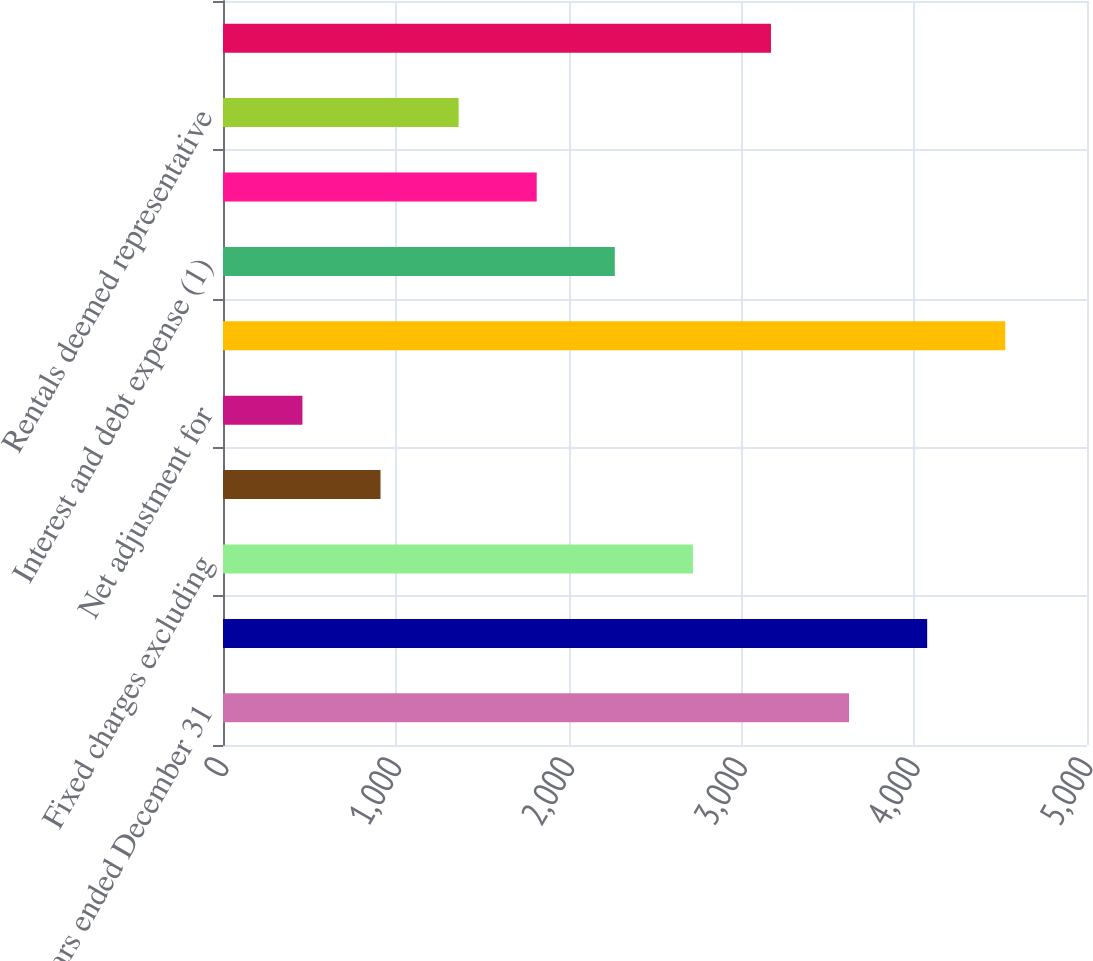<chart> <loc_0><loc_0><loc_500><loc_500><bar_chart><fcel>Years ended December 31<fcel>Earnings before federal taxes<fcel>Fixed charges excluding<fcel>Amortization of previously<fcel>Net adjustment for<fcel>Earnings available for fixed<fcel>Interest and debt expense (1)<fcel>Interest capitalized during<fcel>Rentals deemed representative<fcel>Total fixed charges<nl><fcel>3623.14<fcel>4075.07<fcel>2719.28<fcel>911.56<fcel>459.63<fcel>4527<fcel>2267.35<fcel>1815.42<fcel>1363.49<fcel>3171.21<nl></chart> 